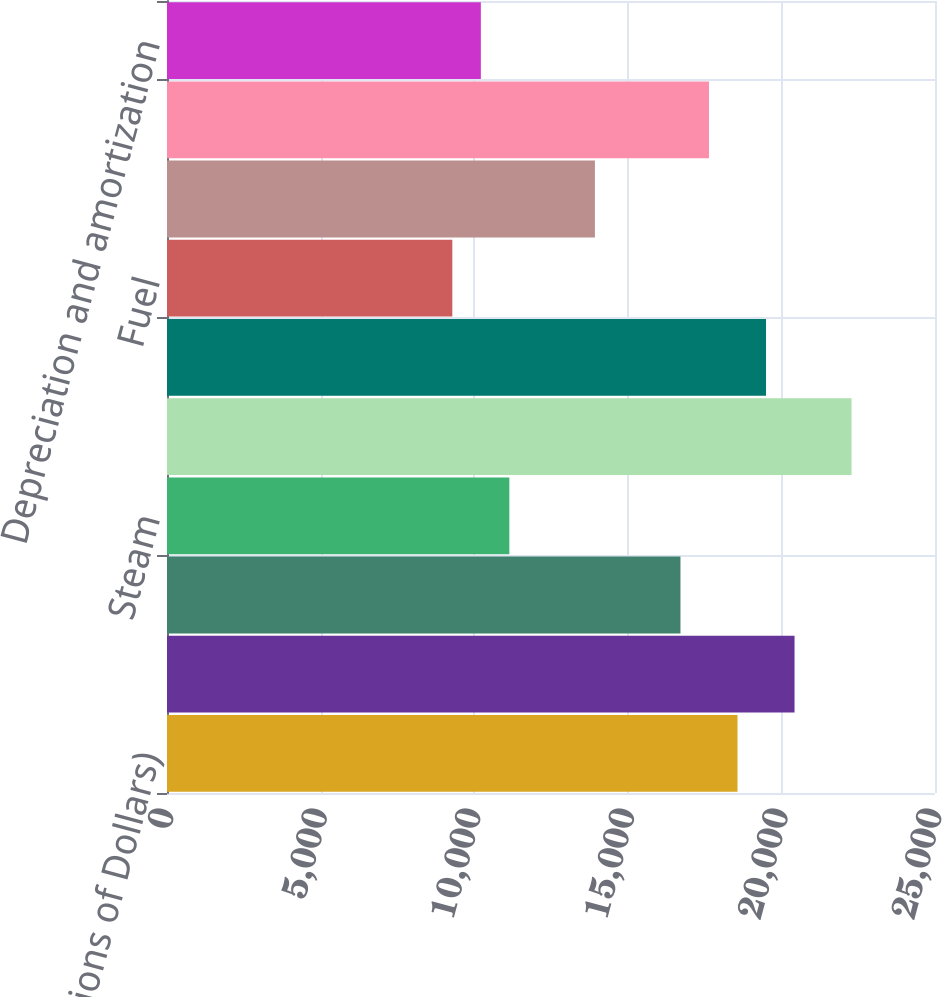<chart> <loc_0><loc_0><loc_500><loc_500><bar_chart><fcel>(Millions of Dollars)<fcel>Electric<fcel>Gas<fcel>Steam<fcel>Revenues Operating Total<fcel>Purchased power<fcel>Fuel<fcel>Gas purchased for resale<fcel>Other operations and<fcel>Depreciation and amortization<nl><fcel>18571<fcel>20427.6<fcel>16714.4<fcel>11144.6<fcel>22284.2<fcel>19499.3<fcel>9288<fcel>13929.5<fcel>17642.7<fcel>10216.3<nl></chart> 